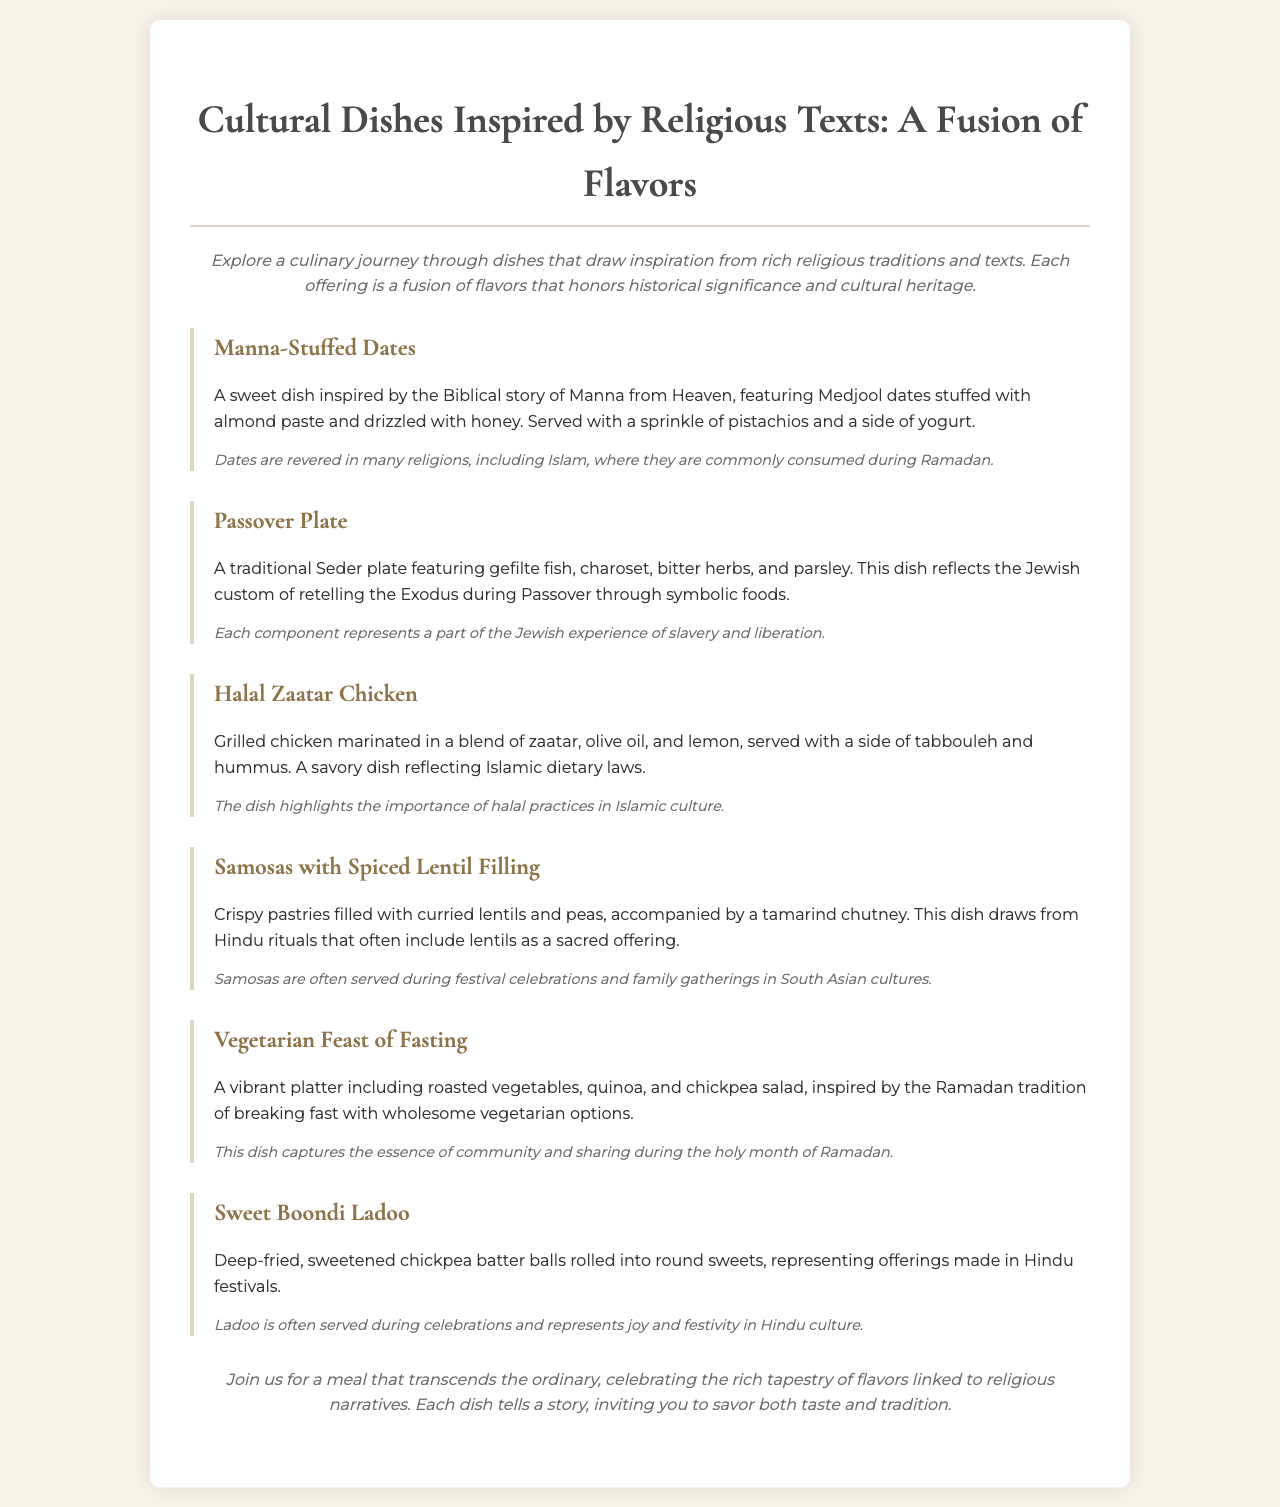What is the first dish listed on the menu? The first dish in the menu is "Manna-Stuffed Dates."
Answer: Manna-Stuffed Dates Which dish features gefilte fish? The dish that includes gefilte fish is part of the "Passover Plate."
Answer: Passover Plate What is the main ingredient in Halal Zaatar Chicken? The main ingredient for Halal Zaatar Chicken is grilled chicken.
Answer: Grilled chicken How many words describe the "Sweet Boondi Ladoo"? The description of Sweet Boondi Ladoo contains a total of 23 words.
Answer: 23 words What does the Vegetarian Feast of Fasting represent? The Vegetarian Feast of Fasting captures the essence of community and sharing during Ramadan.
Answer: Community and sharing Which dish is often served during Hindu festivals? The dish that is often served during Hindu festivals is "Sweet Boondi Ladoo."
Answer: Sweet Boondi Ladoo What type of cuisine does Samosas with Spiced Lentil Filling represent? Samosas with Spiced Lentil Filling represents South Asian cuisine.
Answer: South Asian cuisine What is drizzled on the Manna-Stuffed Dates? Honey is drizzled on the Manna-Stuffed Dates.
Answer: Honey 